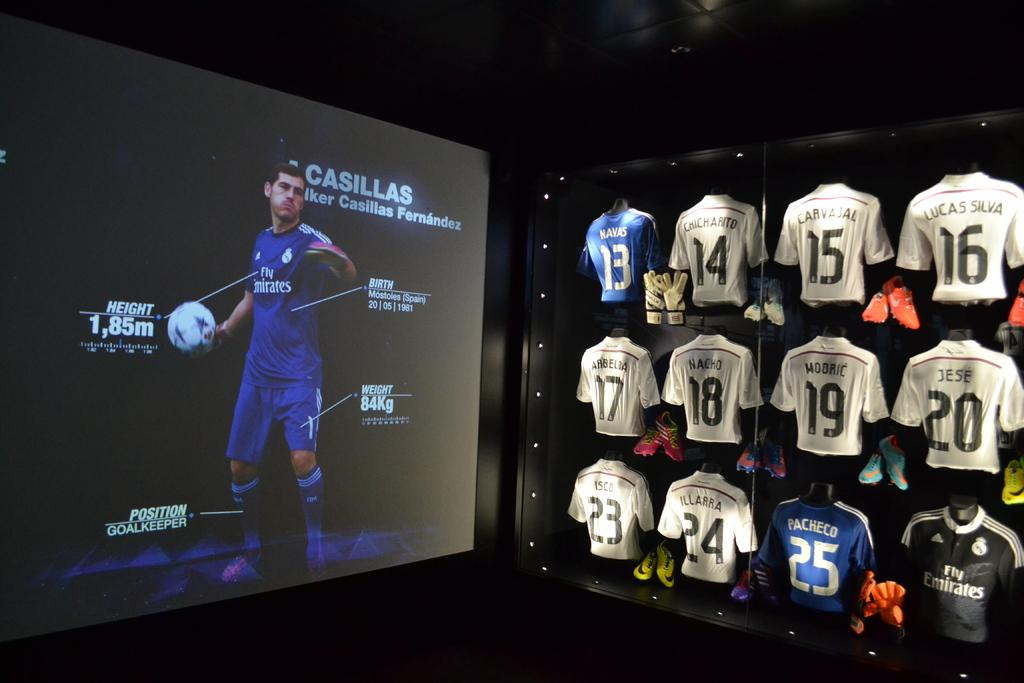<image>
Describe the image concisely. The player on the screen is Casillas who is a golakeeper 